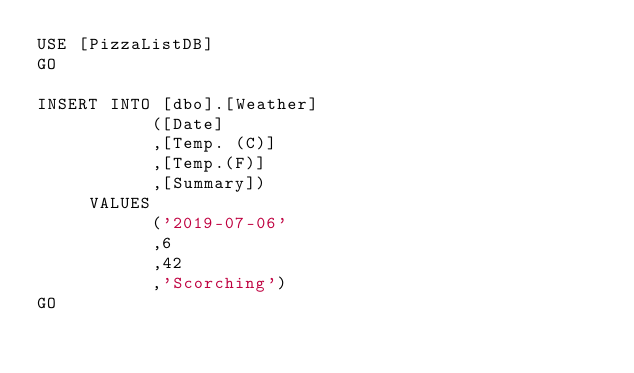<code> <loc_0><loc_0><loc_500><loc_500><_SQL_>USE [PizzaListDB]
GO

INSERT INTO [dbo].[Weather]
           ([Date]
           ,[Temp. (C)]
           ,[Temp.(F)]
           ,[Summary])
     VALUES
           ('2019-07-06'
           ,6
           ,42
           ,'Scorching')
GO


</code> 